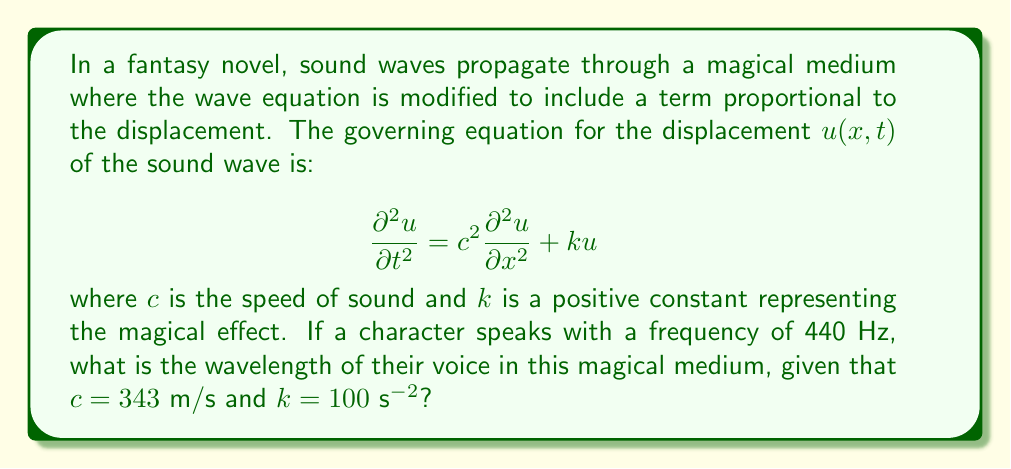Can you solve this math problem? To solve this problem, we need to follow these steps:

1) For a wave equation with an additional term, we assume a solution of the form:
   $$u(x,t) = Ae^{i(ωt - κx)}$$
   where $ω = 2πf$ is the angular frequency and $κ$ is the wavenumber.

2) Substituting this into the given equation:
   $$-ω^2Ae^{i(ωt - κx)} = -c^2κ^2Ae^{i(ωt - κx)} + kAe^{i(ωt - κx)}$$

3) Cancelling $Ae^{i(ωt - κx)}$ from both sides:
   $$ω^2 = c^2κ^2 - k$$

4) Rearranging to solve for $κ$:
   $$κ = \sqrt{\frac{ω^2 + k}{c^2}}$$

5) The wavelength $λ$ is related to the wavenumber by $κ = \frac{2π}{λ}$, so:
   $$λ = \frac{2π}{κ} = \frac{2π}{\sqrt{\frac{ω^2 + k}{c^2}}}$$

6) Given: $f = 440$ Hz, $c = 343$ m/s, $k = 100$ s$^{-2}$
   Calculate $ω = 2πf = 2π(440) ≈ 2763.89$ rad/s

7) Substituting these values:
   $$λ = \frac{2π}{\sqrt{\frac{2763.89^2 + 100}{343^2}}} ≈ 0.7796$$ m

Therefore, the wavelength of the character's voice in this magical medium is approximately 0.7796 meters.
Answer: 0.7796 m 